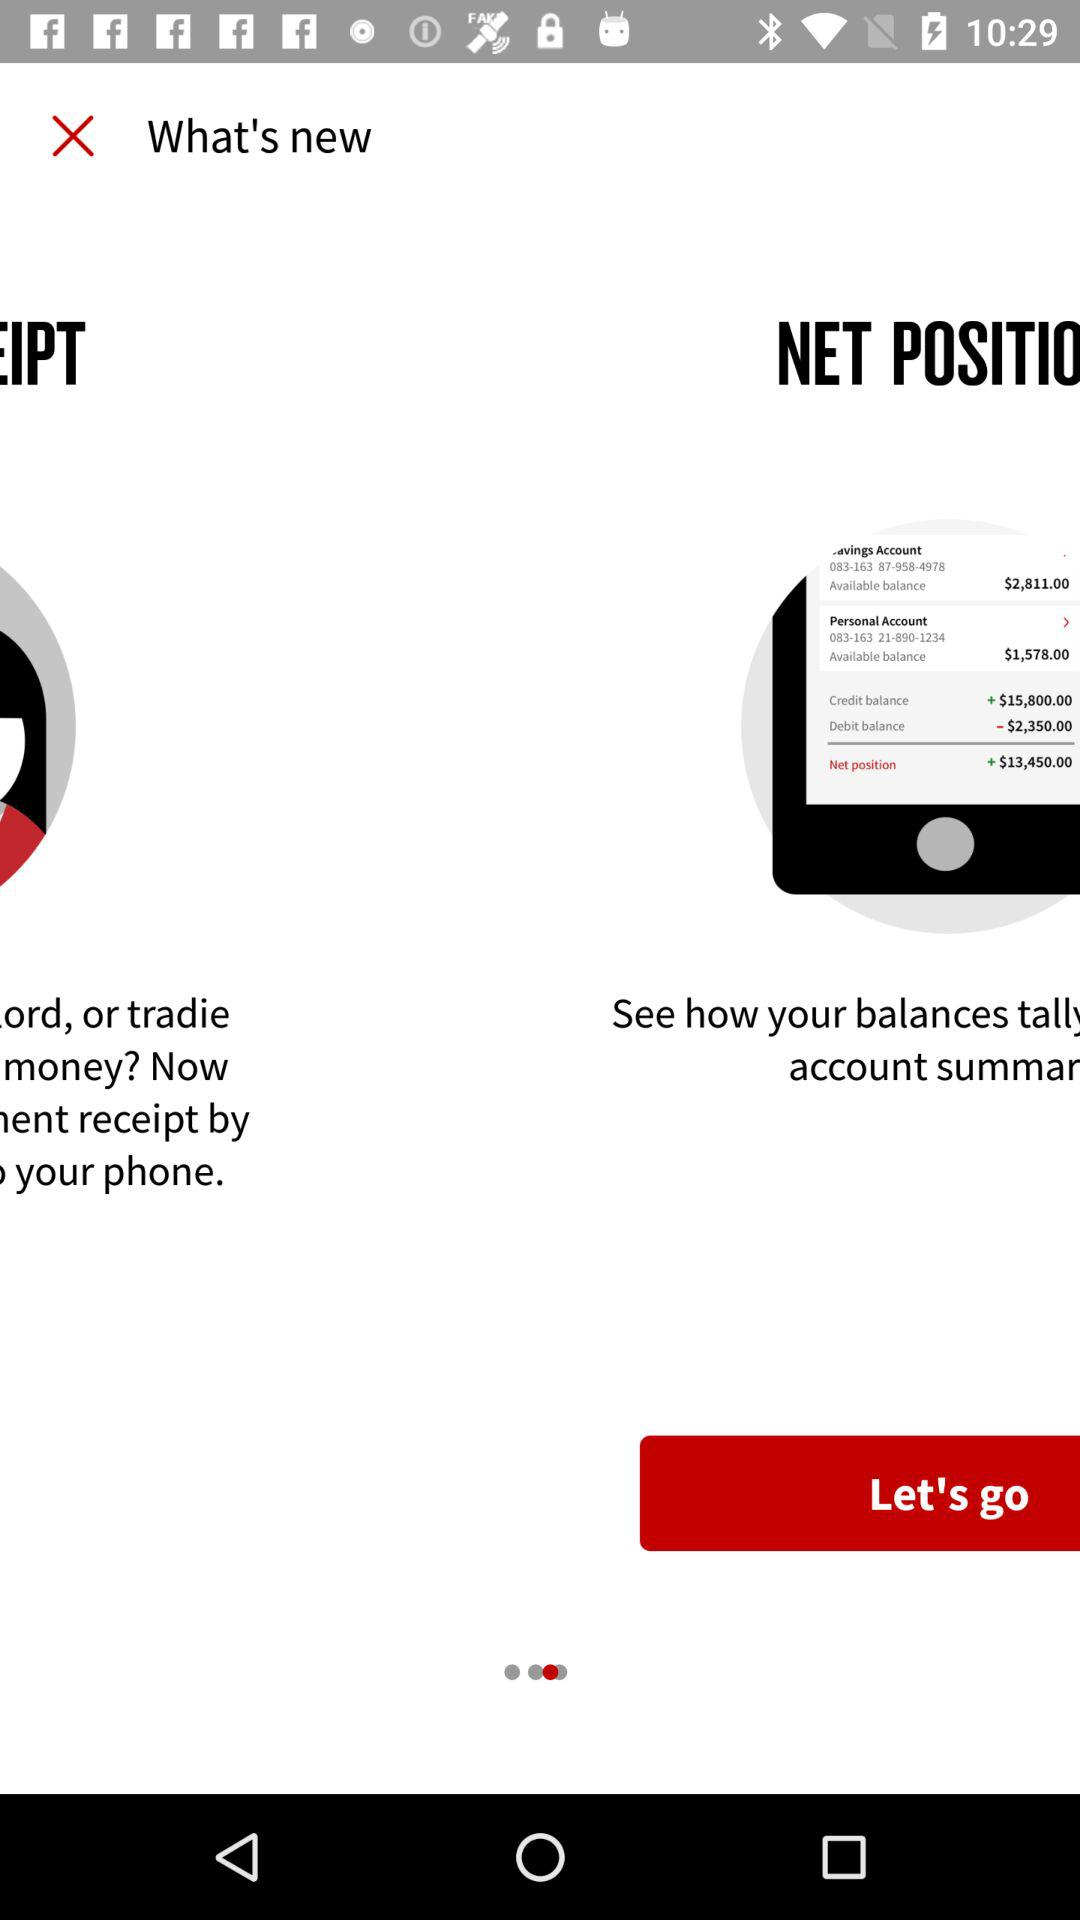What is the credit balance in the saving account? The credit balance is +$15,800.00. 